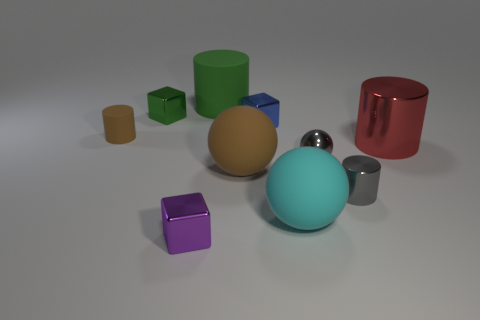There is a blue metallic object that is the same shape as the small green thing; what is its size?
Offer a terse response. Small. How many large cylinders are made of the same material as the tiny green thing?
Your response must be concise. 1. Is the material of the thing that is in front of the big cyan rubber sphere the same as the cyan thing?
Provide a short and direct response. No. Are there the same number of blue things on the right side of the large cyan object and large yellow cylinders?
Your answer should be very brief. Yes. The metallic ball has what size?
Your response must be concise. Small. There is a thing that is the same color as the small shiny sphere; what is its material?
Give a very brief answer. Metal. How many metallic things are the same color as the tiny shiny cylinder?
Offer a very short reply. 1. Do the blue metallic cube and the green metallic block have the same size?
Make the answer very short. Yes. There is a blue shiny thing that is on the right side of the brown rubber thing that is to the right of the green metallic object; how big is it?
Ensure brevity in your answer.  Small. Is the color of the tiny sphere the same as the metal object that is in front of the small gray shiny cylinder?
Your response must be concise. No. 